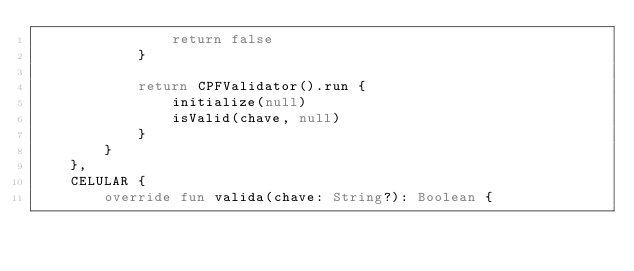Convert code to text. <code><loc_0><loc_0><loc_500><loc_500><_Kotlin_>                return false
            }

            return CPFValidator().run {
                initialize(null)
                isValid(chave, null)
            }
        }
    },
    CELULAR {
        override fun valida(chave: String?): Boolean {</code> 